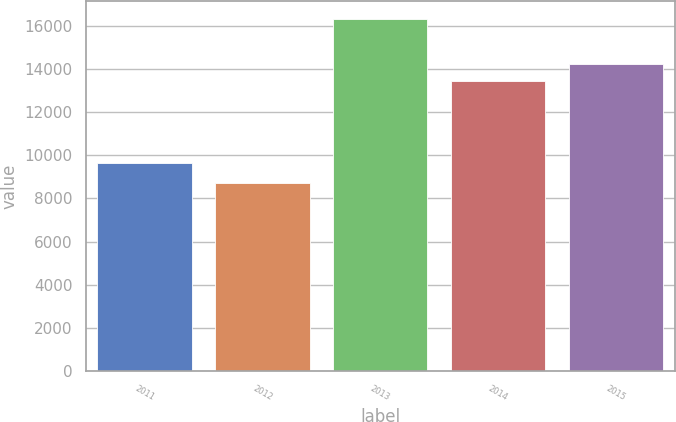Convert chart to OTSL. <chart><loc_0><loc_0><loc_500><loc_500><bar_chart><fcel>2011<fcel>2012<fcel>2013<fcel>2014<fcel>2015<nl><fcel>9637<fcel>8716<fcel>16334<fcel>13451<fcel>14212.8<nl></chart> 